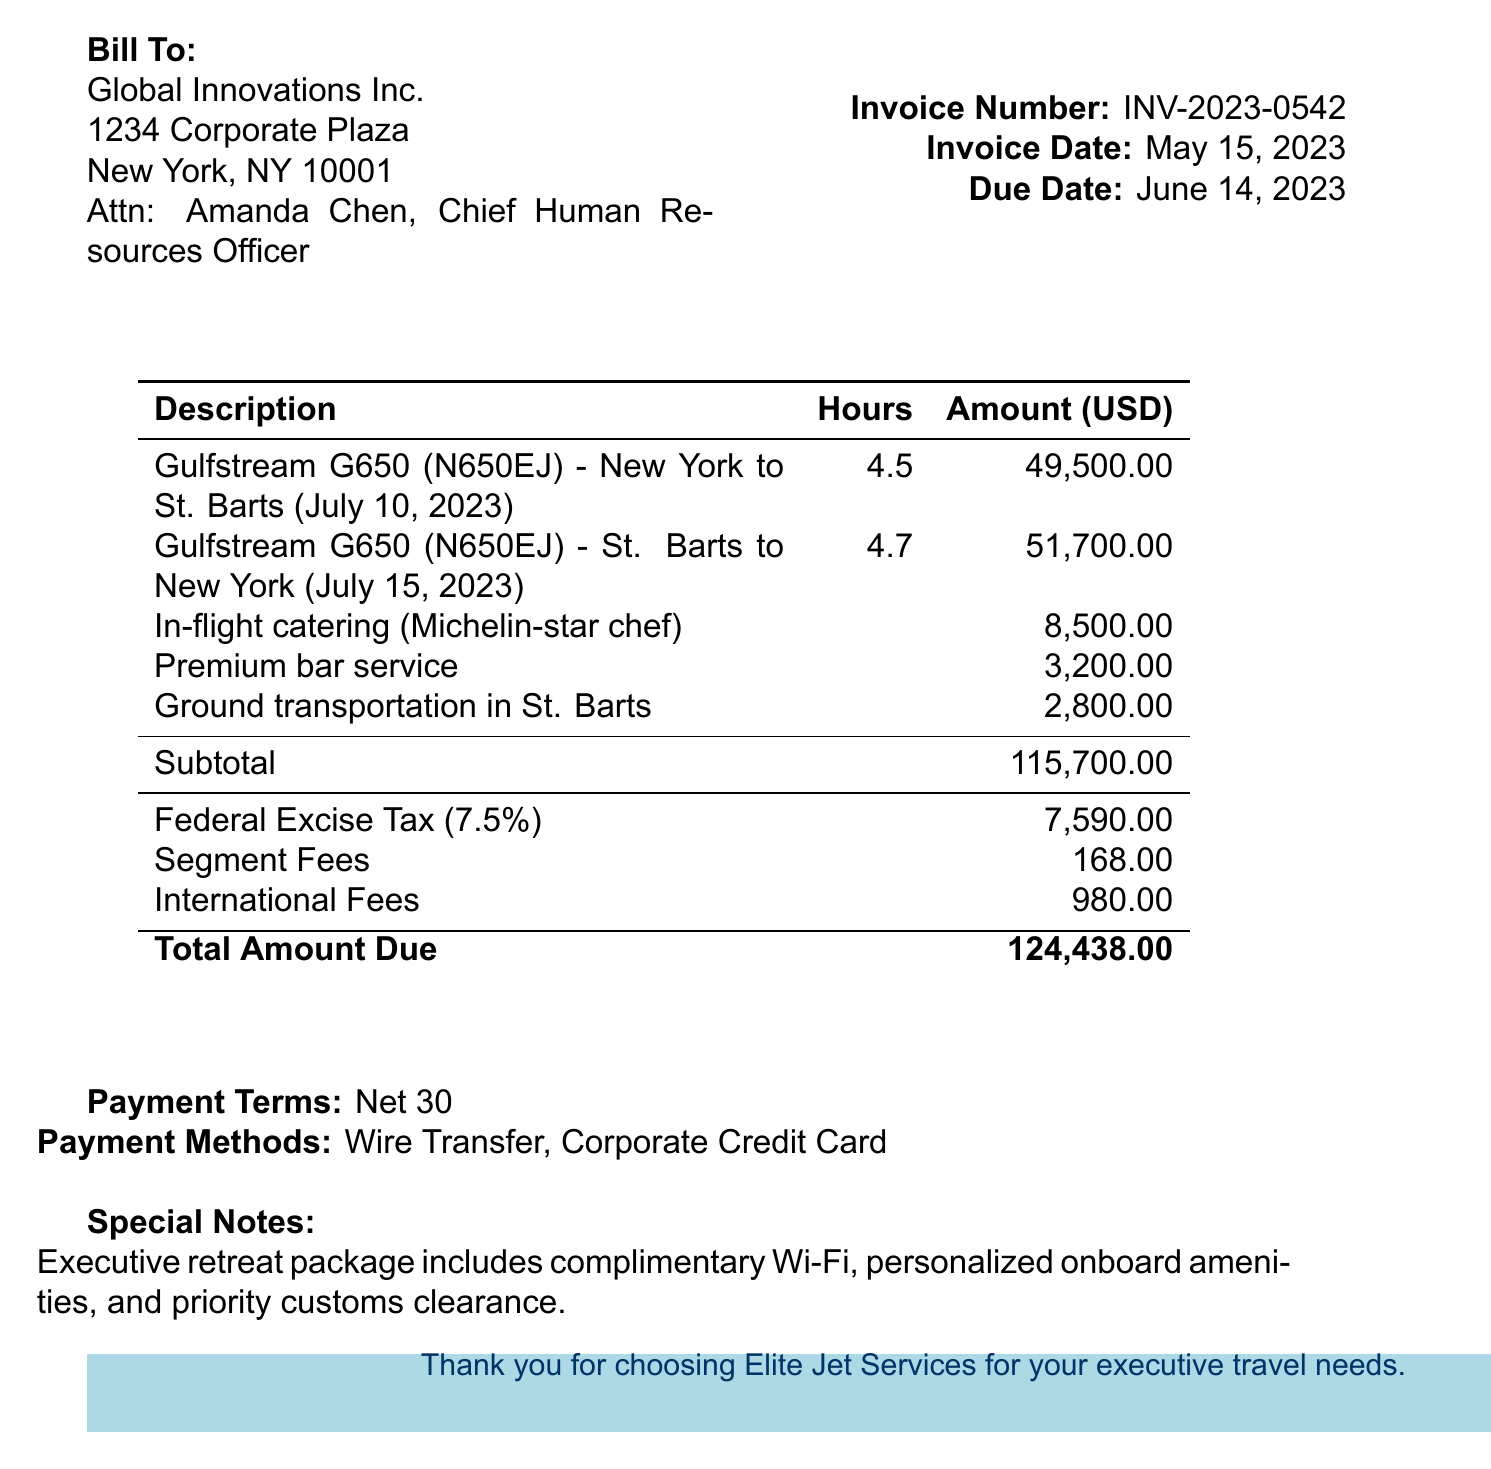What is the invoice number? The invoice number is a unique identifier for this billing statement.
Answer: INV-2023-0542 What is the payment terms? Payment terms specify the time frame within which the payment should be made.
Answer: Net 30 Who is the contact person for the billing statement? The contact person is the representative from the billed company for any inquiries.
Answer: Amanda Chen, Chief Human Resources Officer What is the total amount due? The total amount due represents the total cost for the services rendered.
Answer: 124438.00 What type of aircraft was used for the charter? This information indicates the aircraft model utilized for the flights.
Answer: Gulfstream G650 How many passengers were on the charter flight to St. Barts? The number of passengers gives an idea of the size of the group traveling.
Answer: 14 What additional service costs for ground transportation in St. Barts? Understanding additional services helps set expectations on the overall expenses.
Answer: 2800.00 What is the date of the first flight? This date is crucial for planning and scheduling purposes.
Answer: 2023-07-10 What is included in the executive retreat package? This information summarizes the benefits included in the package.
Answer: complimentary Wi-Fi, personalized onboard amenities, and priority customs clearance 